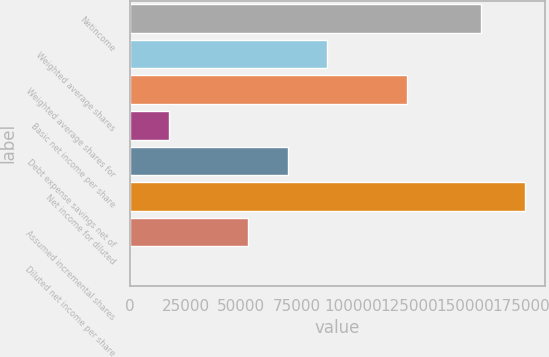<chart> <loc_0><loc_0><loc_500><loc_500><bar_chart><fcel>Netincome<fcel>Weighted average shares<fcel>Weighted average shares for<fcel>Basic net income per share<fcel>Debt expense savings net of<fcel>Net income for diluted<fcel>Assumed incremental shares<fcel>Diluted net income per share<nl><fcel>157329<fcel>88496<fcel>123894<fcel>17700.8<fcel>70797.2<fcel>176990<fcel>53098.4<fcel>1.96<nl></chart> 